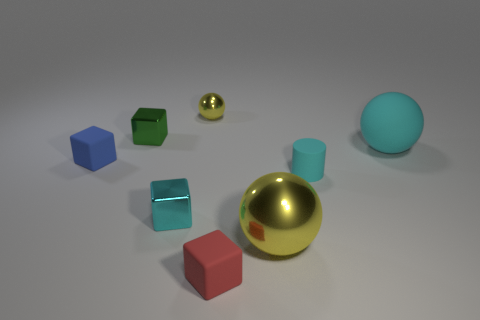Subtract all cyan cylinders. How many yellow spheres are left? 2 Subtract all small red blocks. How many blocks are left? 3 Subtract all cyan blocks. How many blocks are left? 3 Add 1 cyan matte objects. How many objects exist? 9 Subtract all gray spheres. Subtract all blue cubes. How many spheres are left? 3 Subtract all cyan balls. Subtract all red rubber objects. How many objects are left? 6 Add 6 blue matte objects. How many blue matte objects are left? 7 Add 1 small gray matte cubes. How many small gray matte cubes exist? 1 Subtract 0 green cylinders. How many objects are left? 8 Subtract all balls. How many objects are left? 5 